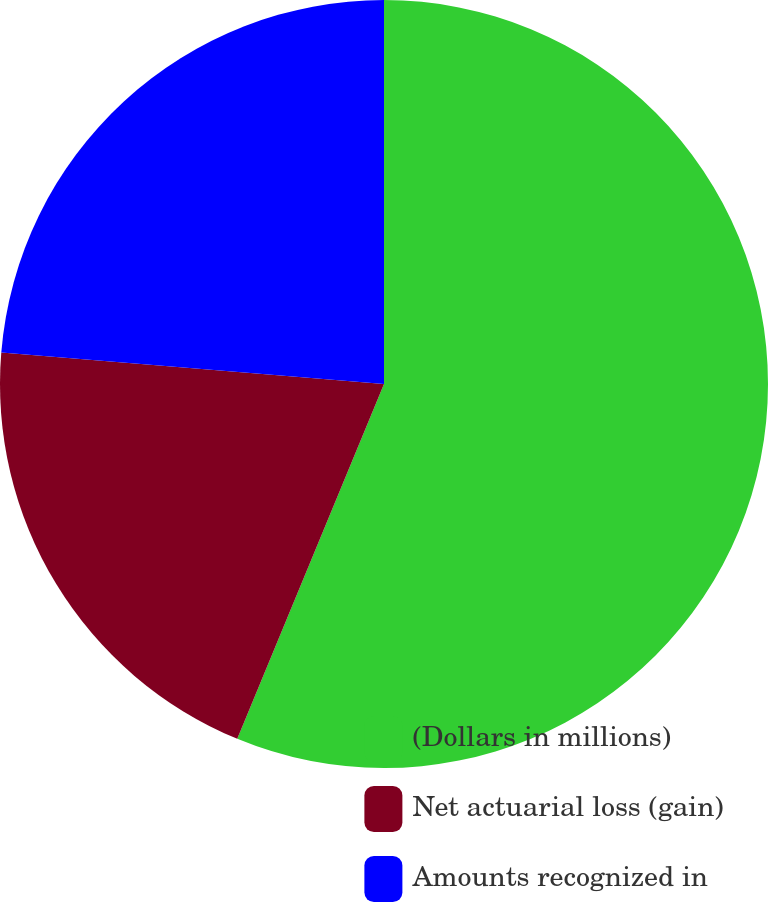<chart> <loc_0><loc_0><loc_500><loc_500><pie_chart><fcel>(Dollars in millions)<fcel>Net actuarial loss (gain)<fcel>Amounts recognized in<nl><fcel>56.24%<fcel>20.07%<fcel>23.69%<nl></chart> 